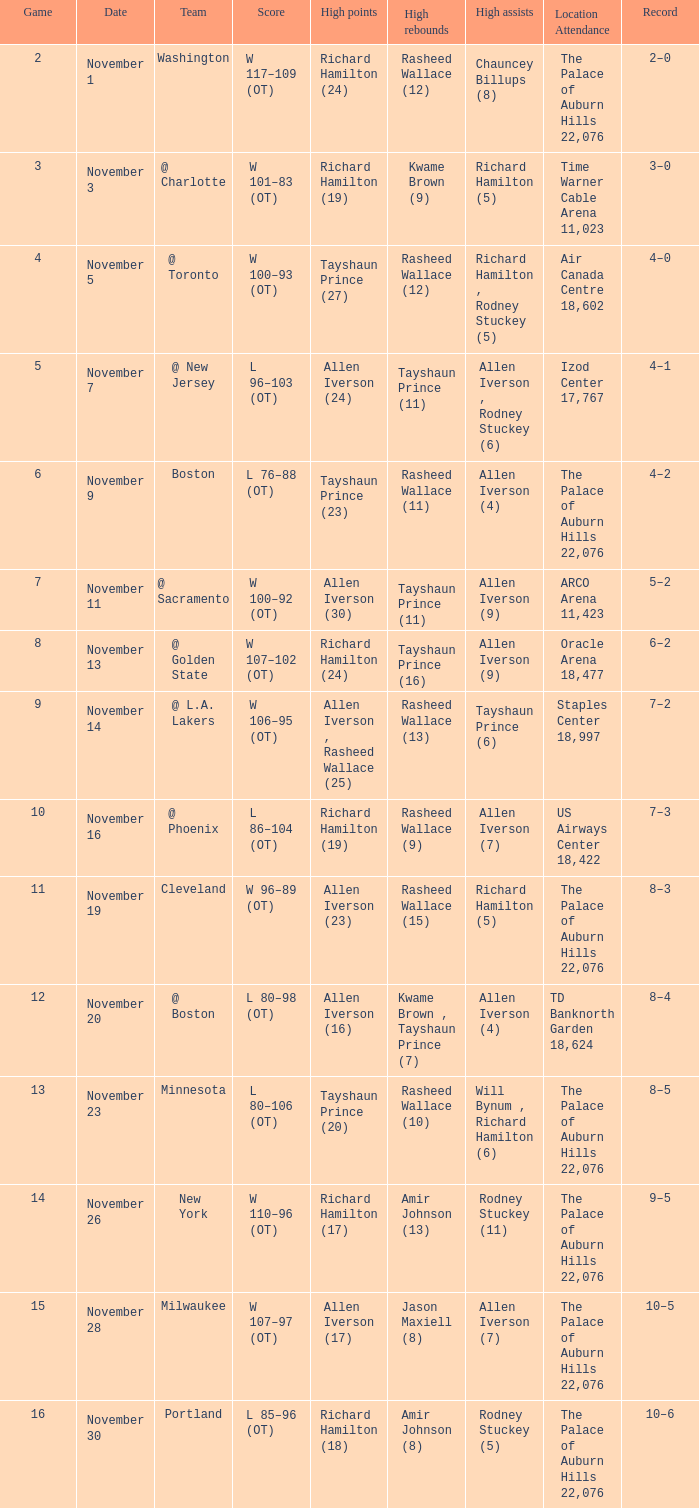Could you parse the entire table as a dict? {'header': ['Game', 'Date', 'Team', 'Score', 'High points', 'High rebounds', 'High assists', 'Location Attendance', 'Record'], 'rows': [['2', 'November 1', 'Washington', 'W 117–109 (OT)', 'Richard Hamilton (24)', 'Rasheed Wallace (12)', 'Chauncey Billups (8)', 'The Palace of Auburn Hills 22,076', '2–0'], ['3', 'November 3', '@ Charlotte', 'W 101–83 (OT)', 'Richard Hamilton (19)', 'Kwame Brown (9)', 'Richard Hamilton (5)', 'Time Warner Cable Arena 11,023', '3–0'], ['4', 'November 5', '@ Toronto', 'W 100–93 (OT)', 'Tayshaun Prince (27)', 'Rasheed Wallace (12)', 'Richard Hamilton , Rodney Stuckey (5)', 'Air Canada Centre 18,602', '4–0'], ['5', 'November 7', '@ New Jersey', 'L 96–103 (OT)', 'Allen Iverson (24)', 'Tayshaun Prince (11)', 'Allen Iverson , Rodney Stuckey (6)', 'Izod Center 17,767', '4–1'], ['6', 'November 9', 'Boston', 'L 76–88 (OT)', 'Tayshaun Prince (23)', 'Rasheed Wallace (11)', 'Allen Iverson (4)', 'The Palace of Auburn Hills 22,076', '4–2'], ['7', 'November 11', '@ Sacramento', 'W 100–92 (OT)', 'Allen Iverson (30)', 'Tayshaun Prince (11)', 'Allen Iverson (9)', 'ARCO Arena 11,423', '5–2'], ['8', 'November 13', '@ Golden State', 'W 107–102 (OT)', 'Richard Hamilton (24)', 'Tayshaun Prince (16)', 'Allen Iverson (9)', 'Oracle Arena 18,477', '6–2'], ['9', 'November 14', '@ L.A. Lakers', 'W 106–95 (OT)', 'Allen Iverson , Rasheed Wallace (25)', 'Rasheed Wallace (13)', 'Tayshaun Prince (6)', 'Staples Center 18,997', '7–2'], ['10', 'November 16', '@ Phoenix', 'L 86–104 (OT)', 'Richard Hamilton (19)', 'Rasheed Wallace (9)', 'Allen Iverson (7)', 'US Airways Center 18,422', '7–3'], ['11', 'November 19', 'Cleveland', 'W 96–89 (OT)', 'Allen Iverson (23)', 'Rasheed Wallace (15)', 'Richard Hamilton (5)', 'The Palace of Auburn Hills 22,076', '8–3'], ['12', 'November 20', '@ Boston', 'L 80–98 (OT)', 'Allen Iverson (16)', 'Kwame Brown , Tayshaun Prince (7)', 'Allen Iverson (4)', 'TD Banknorth Garden 18,624', '8–4'], ['13', 'November 23', 'Minnesota', 'L 80–106 (OT)', 'Tayshaun Prince (20)', 'Rasheed Wallace (10)', 'Will Bynum , Richard Hamilton (6)', 'The Palace of Auburn Hills 22,076', '8–5'], ['14', 'November 26', 'New York', 'W 110–96 (OT)', 'Richard Hamilton (17)', 'Amir Johnson (13)', 'Rodney Stuckey (11)', 'The Palace of Auburn Hills 22,076', '9–5'], ['15', 'November 28', 'Milwaukee', 'W 107–97 (OT)', 'Allen Iverson (17)', 'Jason Maxiell (8)', 'Allen Iverson (7)', 'The Palace of Auburn Hills 22,076', '10–5'], ['16', 'November 30', 'Portland', 'L 85–96 (OT)', 'Richard Hamilton (18)', 'Amir Johnson (8)', 'Rodney Stuckey (5)', 'The Palace of Auburn Hills 22,076', '10–6']]} What is the mean game performance for the team "milwaukee"? 15.0. 